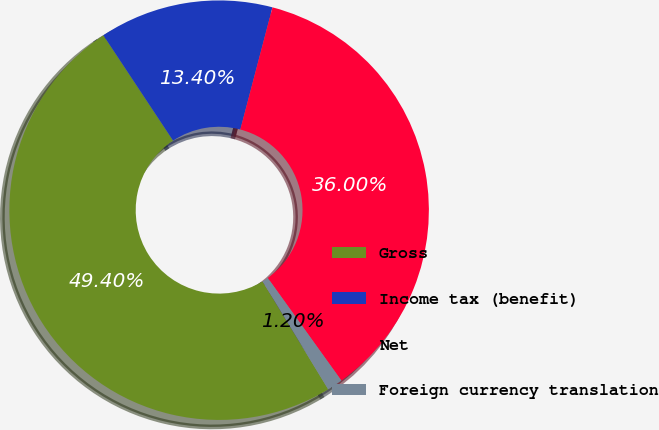<chart> <loc_0><loc_0><loc_500><loc_500><pie_chart><fcel>Gross<fcel>Income tax (benefit)<fcel>Net<fcel>Foreign currency translation<nl><fcel>49.4%<fcel>13.4%<fcel>36.0%<fcel>1.2%<nl></chart> 